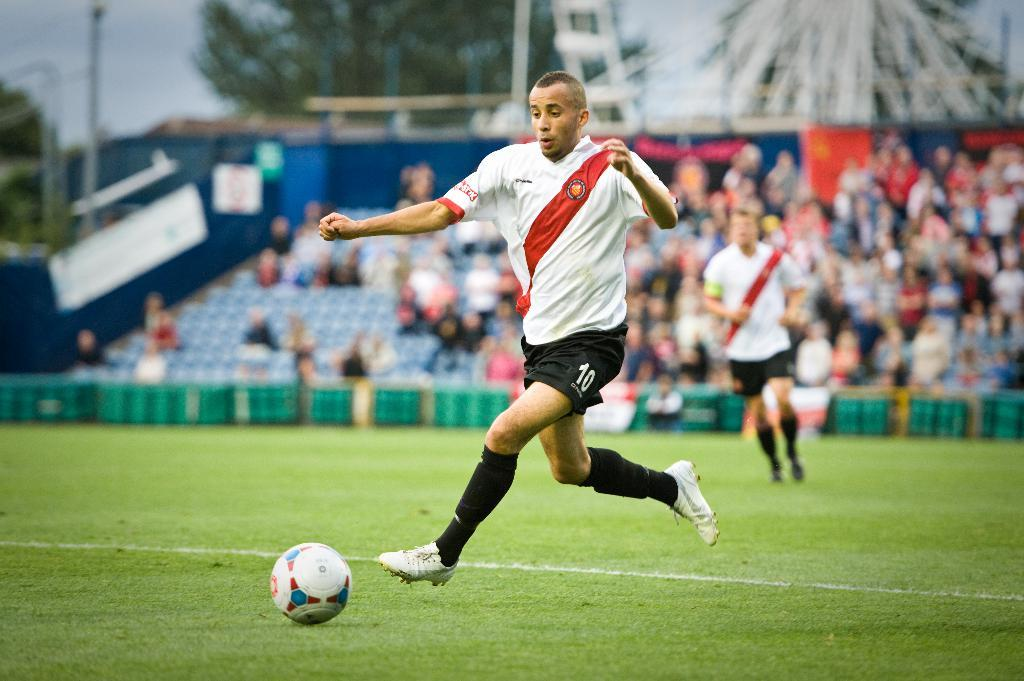<image>
Relay a brief, clear account of the picture shown. A soccer player in number 10 shorts runs after the ball 